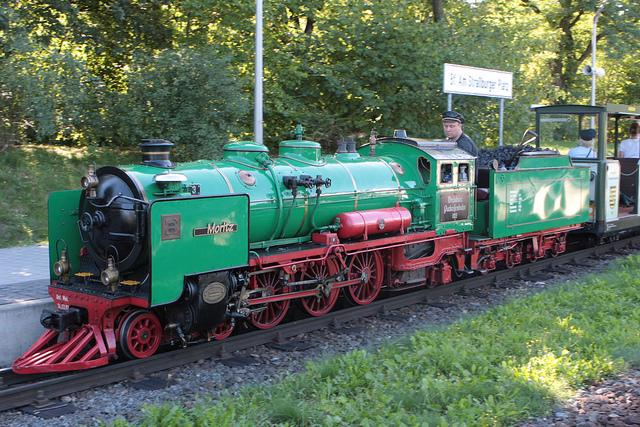What is the man doing at the front of the train car? driving 